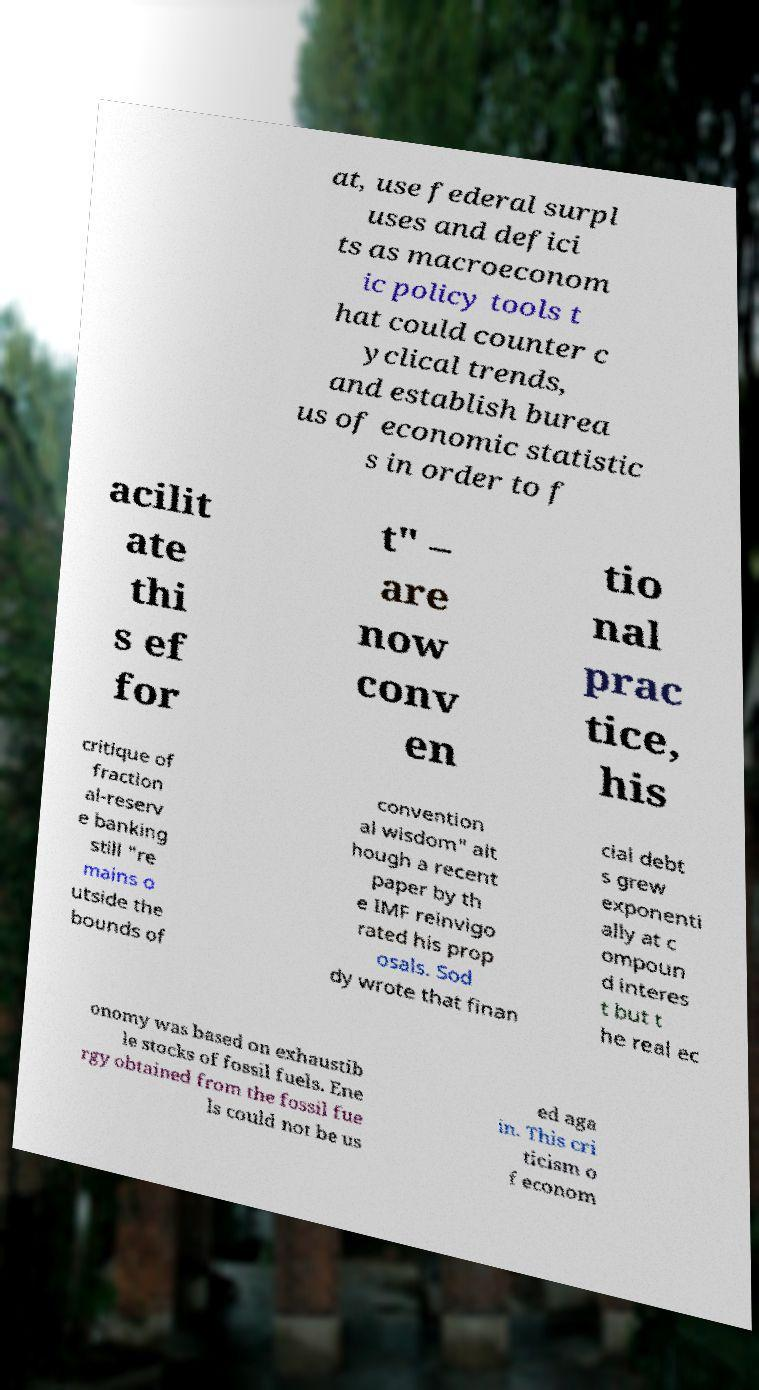Could you assist in decoding the text presented in this image and type it out clearly? at, use federal surpl uses and defici ts as macroeconom ic policy tools t hat could counter c yclical trends, and establish burea us of economic statistic s in order to f acilit ate thi s ef for t" – are now conv en tio nal prac tice, his critique of fraction al-reserv e banking still "re mains o utside the bounds of convention al wisdom" alt hough a recent paper by th e IMF reinvigo rated his prop osals. Sod dy wrote that finan cial debt s grew exponenti ally at c ompoun d interes t but t he real ec onomy was based on exhaustib le stocks of fossil fuels. Ene rgy obtained from the fossil fue ls could not be us ed aga in. This cri ticism o f econom 